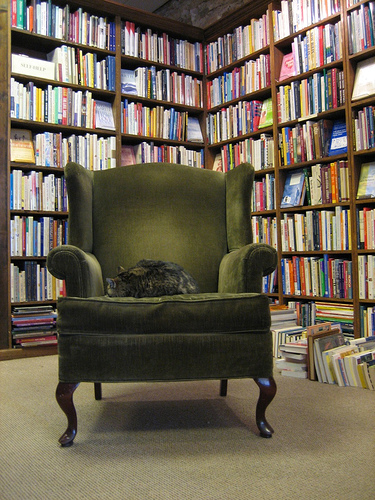<image>
Can you confirm if the cat is on the chair? Yes. Looking at the image, I can see the cat is positioned on top of the chair, with the chair providing support. Where is the book in relation to the chair? Is it on the chair? No. The book is not positioned on the chair. They may be near each other, but the book is not supported by or resting on top of the chair. Is the chair next to the bookshelf? Yes. The chair is positioned adjacent to the bookshelf, located nearby in the same general area. Is there a book to the left of the cat? No. The book is not to the left of the cat. From this viewpoint, they have a different horizontal relationship. 